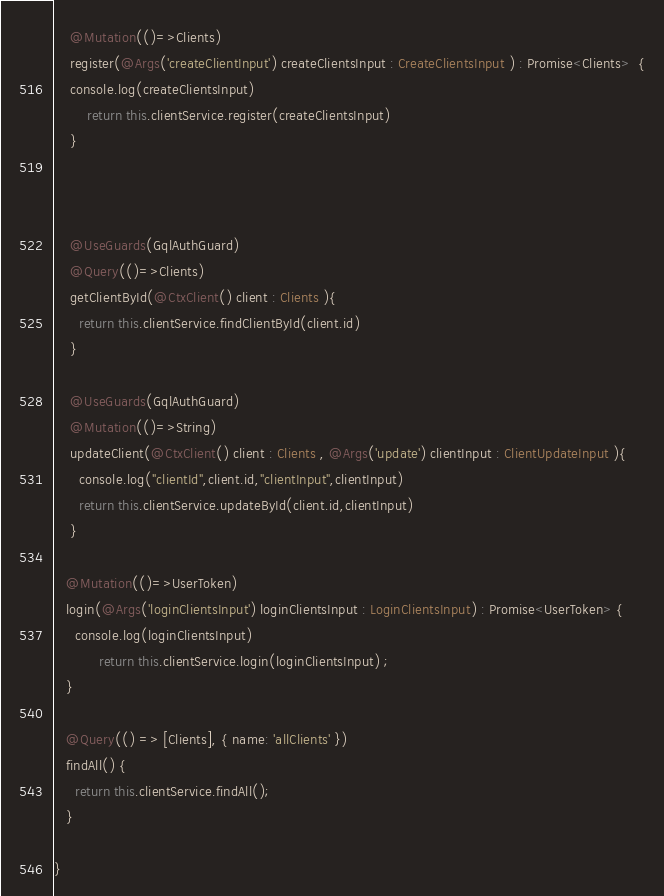<code> <loc_0><loc_0><loc_500><loc_500><_TypeScript_>    @Mutation(()=>Clients)
    register(@Args('createClientInput') createClientsInput : CreateClientsInput ) : Promise<Clients>  {
    console.log(createClientsInput)
        return this.clientService.register(createClientsInput) 
    }

 

    @UseGuards(GqlAuthGuard)
    @Query(()=>Clients)
    getClientById(@CtxClient() client : Clients ){
      return this.clientService.findClientById(client.id) 
    }

    @UseGuards(GqlAuthGuard)
    @Mutation(()=>String)
    updateClient(@CtxClient() client : Clients , @Args('update') clientInput : ClientUpdateInput ){
      console.log("clientId",client.id,"clientInput",clientInput)
      return this.clientService.updateById(client.id,clientInput)
    }

   @Mutation(()=>UserToken)
   login(@Args('loginClientsInput') loginClientsInput : LoginClientsInput) : Promise<UserToken> {
     console.log(loginClientsInput)
           return this.clientService.login(loginClientsInput) ; 
   }

   @Query(() => [Clients], { name: 'allClients' })
   findAll() {
     return this.clientService.findAll();
   }

}

</code> 